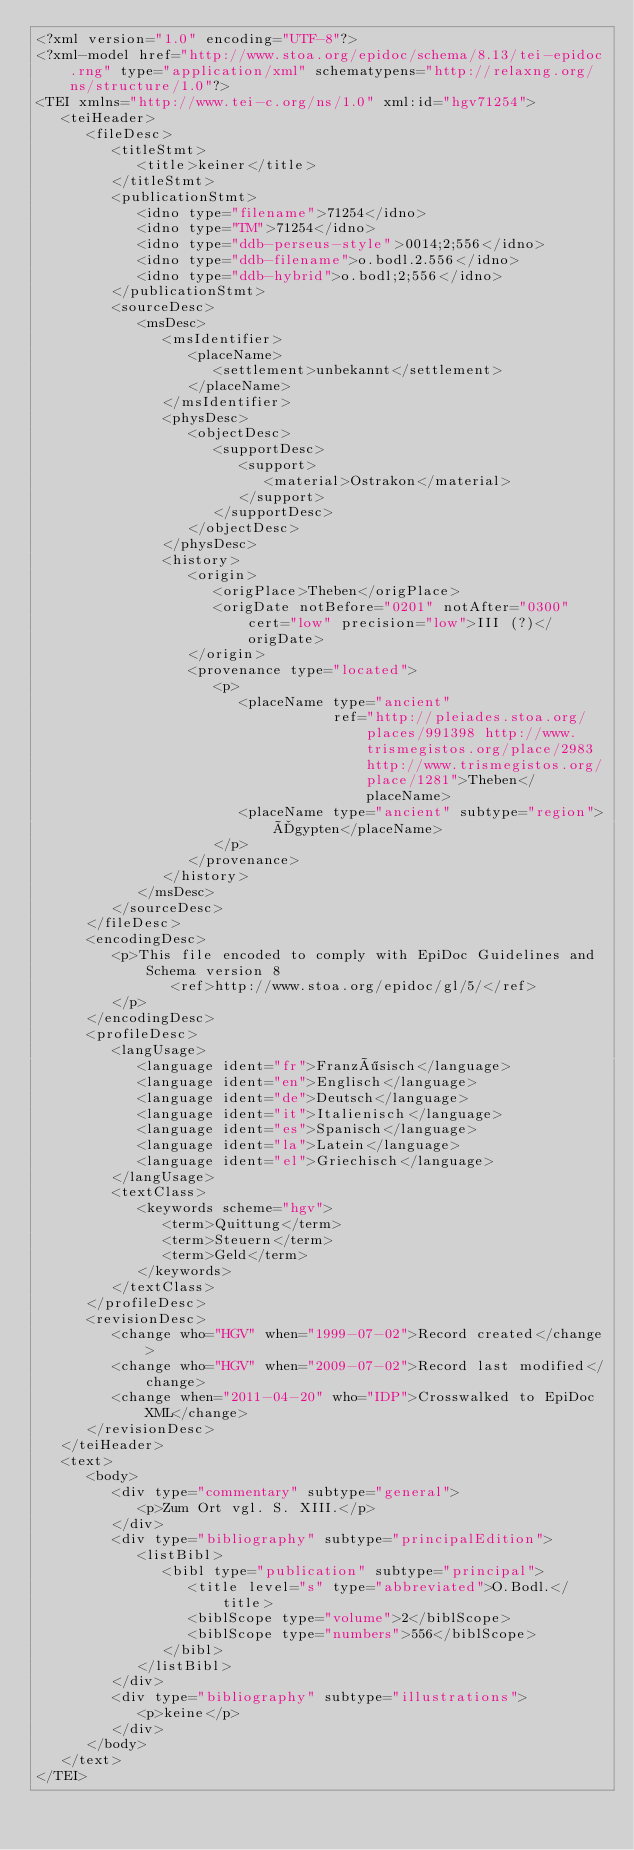Convert code to text. <code><loc_0><loc_0><loc_500><loc_500><_XML_><?xml version="1.0" encoding="UTF-8"?>
<?xml-model href="http://www.stoa.org/epidoc/schema/8.13/tei-epidoc.rng" type="application/xml" schematypens="http://relaxng.org/ns/structure/1.0"?>
<TEI xmlns="http://www.tei-c.org/ns/1.0" xml:id="hgv71254">
   <teiHeader>
      <fileDesc>
         <titleStmt>
            <title>keiner</title>
         </titleStmt>
         <publicationStmt>
            <idno type="filename">71254</idno>
            <idno type="TM">71254</idno>
            <idno type="ddb-perseus-style">0014;2;556</idno>
            <idno type="ddb-filename">o.bodl.2.556</idno>
            <idno type="ddb-hybrid">o.bodl;2;556</idno>
         </publicationStmt>
         <sourceDesc>
            <msDesc>
               <msIdentifier>
                  <placeName>
                     <settlement>unbekannt</settlement>
                  </placeName>
               </msIdentifier>
               <physDesc>
                  <objectDesc>
                     <supportDesc>
                        <support>
                           <material>Ostrakon</material>
                        </support>
                     </supportDesc>
                  </objectDesc>
               </physDesc>
               <history>
                  <origin>
                     <origPlace>Theben</origPlace>
                     <origDate notBefore="0201" notAfter="0300" cert="low" precision="low">III (?)</origDate>
                  </origin>
                  <provenance type="located">
                     <p>
                        <placeName type="ancient"
                                   ref="http://pleiades.stoa.org/places/991398 http://www.trismegistos.org/place/2983 http://www.trismegistos.org/place/1281">Theben</placeName>
                        <placeName type="ancient" subtype="region">Ägypten</placeName>
                     </p>
                  </provenance>
               </history>
            </msDesc>
         </sourceDesc>
      </fileDesc>
      <encodingDesc>
         <p>This file encoded to comply with EpiDoc Guidelines and Schema version 8
                <ref>http://www.stoa.org/epidoc/gl/5/</ref>
         </p>
      </encodingDesc>
      <profileDesc>
         <langUsage>
            <language ident="fr">Französisch</language>
            <language ident="en">Englisch</language>
            <language ident="de">Deutsch</language>
            <language ident="it">Italienisch</language>
            <language ident="es">Spanisch</language>
            <language ident="la">Latein</language>
            <language ident="el">Griechisch</language>
         </langUsage>
         <textClass>
            <keywords scheme="hgv">
               <term>Quittung</term>
               <term>Steuern</term>
               <term>Geld</term>
            </keywords>
         </textClass>
      </profileDesc>
      <revisionDesc>
         <change who="HGV" when="1999-07-02">Record created</change>
         <change who="HGV" when="2009-07-02">Record last modified</change>
         <change when="2011-04-20" who="IDP">Crosswalked to EpiDoc XML</change>
      </revisionDesc>
   </teiHeader>
   <text>
      <body>
         <div type="commentary" subtype="general">
            <p>Zum Ort vgl. S. XIII.</p>
         </div>
         <div type="bibliography" subtype="principalEdition">
            <listBibl>
               <bibl type="publication" subtype="principal">
                  <title level="s" type="abbreviated">O.Bodl.</title>
                  <biblScope type="volume">2</biblScope>
                  <biblScope type="numbers">556</biblScope>
               </bibl>
            </listBibl>
         </div>
         <div type="bibliography" subtype="illustrations">
            <p>keine</p>
         </div>
      </body>
   </text>
</TEI>
</code> 